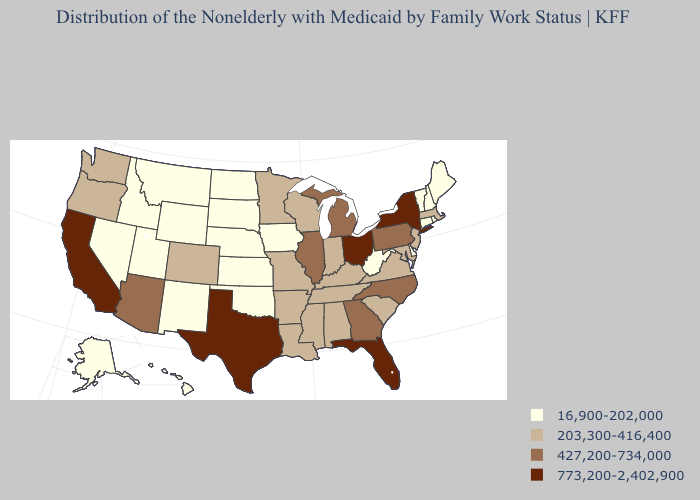Does Texas have the same value as Alaska?
Quick response, please. No. Among the states that border Kentucky , which have the lowest value?
Answer briefly. West Virginia. Does Wisconsin have a higher value than New Hampshire?
Give a very brief answer. Yes. Which states have the highest value in the USA?
Keep it brief. California, Florida, New York, Ohio, Texas. What is the lowest value in the USA?
Short answer required. 16,900-202,000. What is the value of North Dakota?
Short answer required. 16,900-202,000. Name the states that have a value in the range 773,200-2,402,900?
Concise answer only. California, Florida, New York, Ohio, Texas. What is the highest value in the USA?
Keep it brief. 773,200-2,402,900. What is the highest value in the West ?
Be succinct. 773,200-2,402,900. What is the value of Wyoming?
Be succinct. 16,900-202,000. What is the highest value in states that border New York?
Quick response, please. 427,200-734,000. What is the highest value in the USA?
Short answer required. 773,200-2,402,900. What is the value of Louisiana?
Short answer required. 203,300-416,400. Among the states that border South Carolina , which have the highest value?
Write a very short answer. Georgia, North Carolina. Which states have the lowest value in the USA?
Quick response, please. Alaska, Connecticut, Delaware, Hawaii, Idaho, Iowa, Kansas, Maine, Montana, Nebraska, Nevada, New Hampshire, New Mexico, North Dakota, Oklahoma, Rhode Island, South Dakota, Utah, Vermont, West Virginia, Wyoming. 